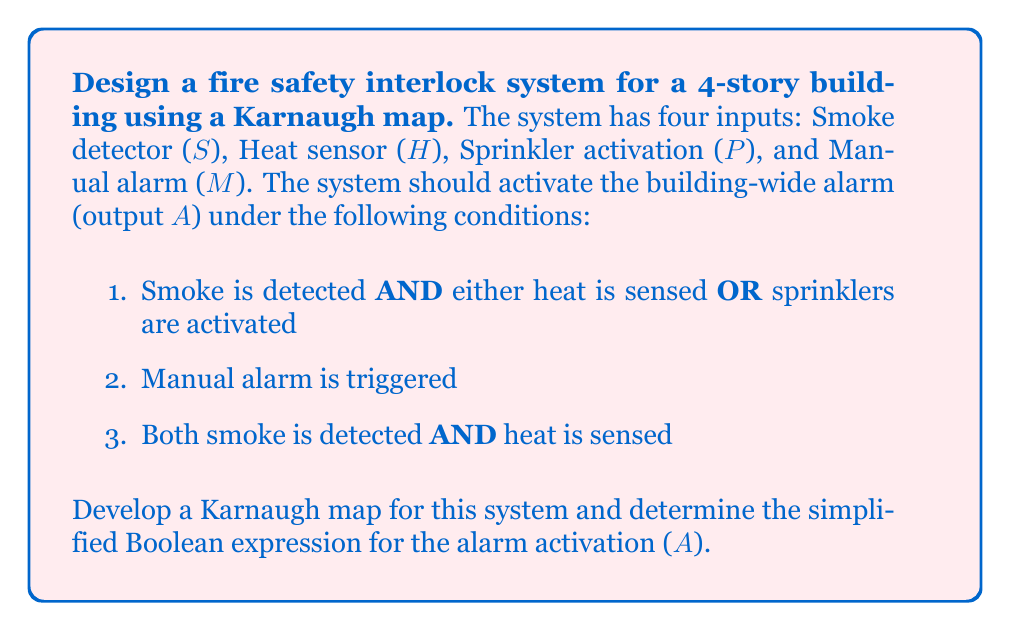What is the answer to this math problem? Let's approach this step-by-step:

1. First, we need to create a truth table for the given conditions:

   S H P M | A
   0 0 0 0 | 0
   0 0 0 1 | 1
   0 0 1 0 | 0
   0 0 1 1 | 1
   0 1 0 0 | 0
   0 1 0 1 | 1
   0 1 1 0 | 0
   0 1 1 1 | 1
   1 0 0 0 | 0
   1 0 0 1 | 1
   1 0 1 0 | 1
   1 0 1 1 | 1
   1 1 0 0 | 1
   1 1 0 1 | 1
   1 1 1 0 | 1
   1 1 1 1 | 1

2. Now, we can create a Karnaugh map using this truth table:

   [asy]
   import geometry;

   size(200);
   
   for(int i=0; i<4; ++i)
     for(int j=0; j<4; ++j)
       draw((i,j)--(i+1,j)--(i+1,j+1)--(i,j+1)--cycle);
   
   label("00", (0.5,4.5));
   label("01", (1.5,4.5));
   label("11", (2.5,4.5));
   label("10", (3.5,4.5));
   
   label("00", (-0.5,3.5));
   label("01", (-0.5,2.5));
   label("11", (-0.5,1.5));
   label("10", (-0.5,0.5));
   
   label("0", (0.5,3.5));
   label("0", (1.5,3.5));
   label("0", (2.5,3.5));
   label("0", (3.5,3.5));
   
   label("1", (0.5,2.5));
   label("1", (1.5,2.5));
   label("1", (2.5,2.5));
   label("1", (3.5,2.5));
   
   label("1", (0.5,1.5));
   label("1", (1.5,1.5));
   label("1", (2.5,1.5));
   label("1", (3.5,1.5));
   
   label("0", (0.5,0.5));
   label("1", (1.5,0.5));
   label("1", (2.5,0.5));
   label("1", (3.5,0.5));
   
   label("SH", (-0.5,4.5));
   label("PM", (4.5,3.5));
   [/asy]

3. From the Karnaugh map, we can identify the following groups:
   - A group of 8 cells for M (manual alarm)
   - A group of 4 cells for SH (smoke and heat)
   - A group of 4 cells for SP (smoke and sprinkler)

4. These groups translate to the following Boolean terms:
   - M
   - SH
   - SP

5. The simplified Boolean expression is the OR of these terms:

   $$A = M + SH + SP$$

This expression satisfies all the given conditions:
- M activates the alarm (condition 2)
- SH activates the alarm (condition 3)
- S(H+P) is covered by SH and SP (condition 1)
Answer: $$A = M + SH + SP$$ 